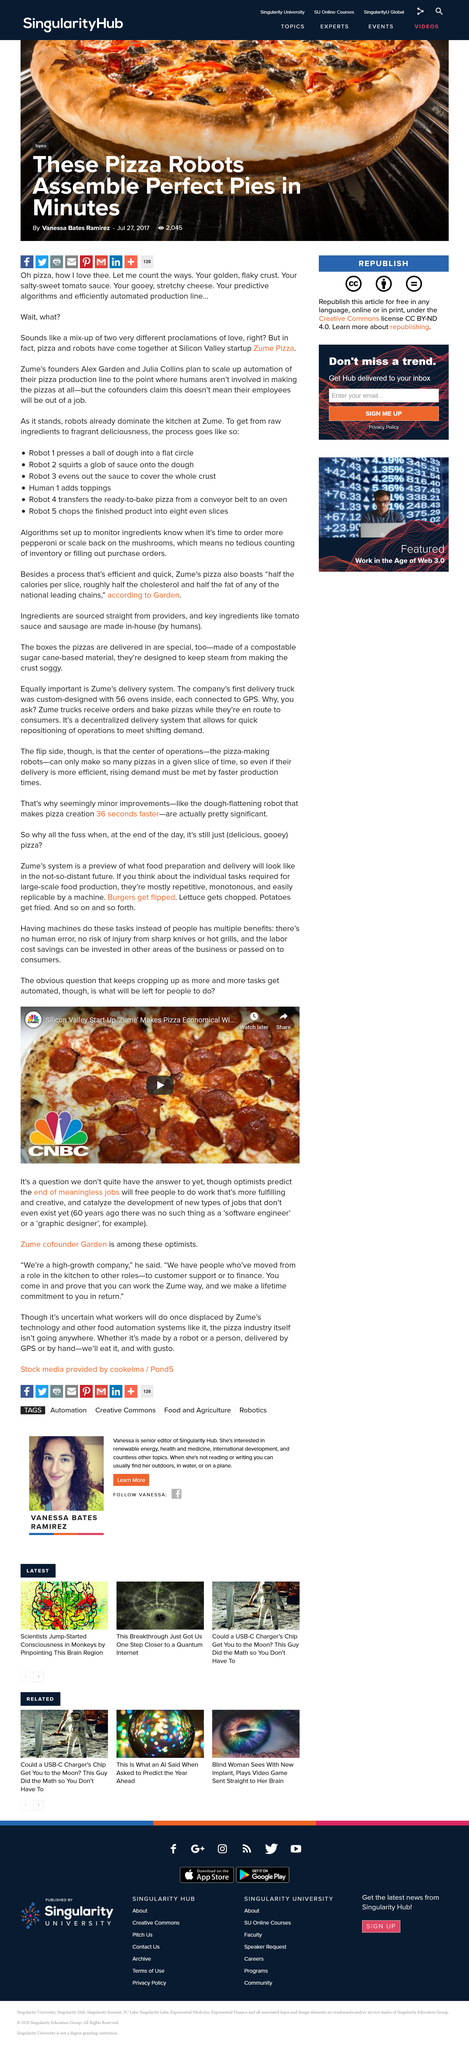Draw attention to some important aspects in this diagram. Zume's founders are Alex Garden and Julia Collins. Zume uses a total of five robots to produce each pizza. At the Silicon Valley startup Zume Pizza, pizza and robots have come together to create a unique and innovative dining experience. 